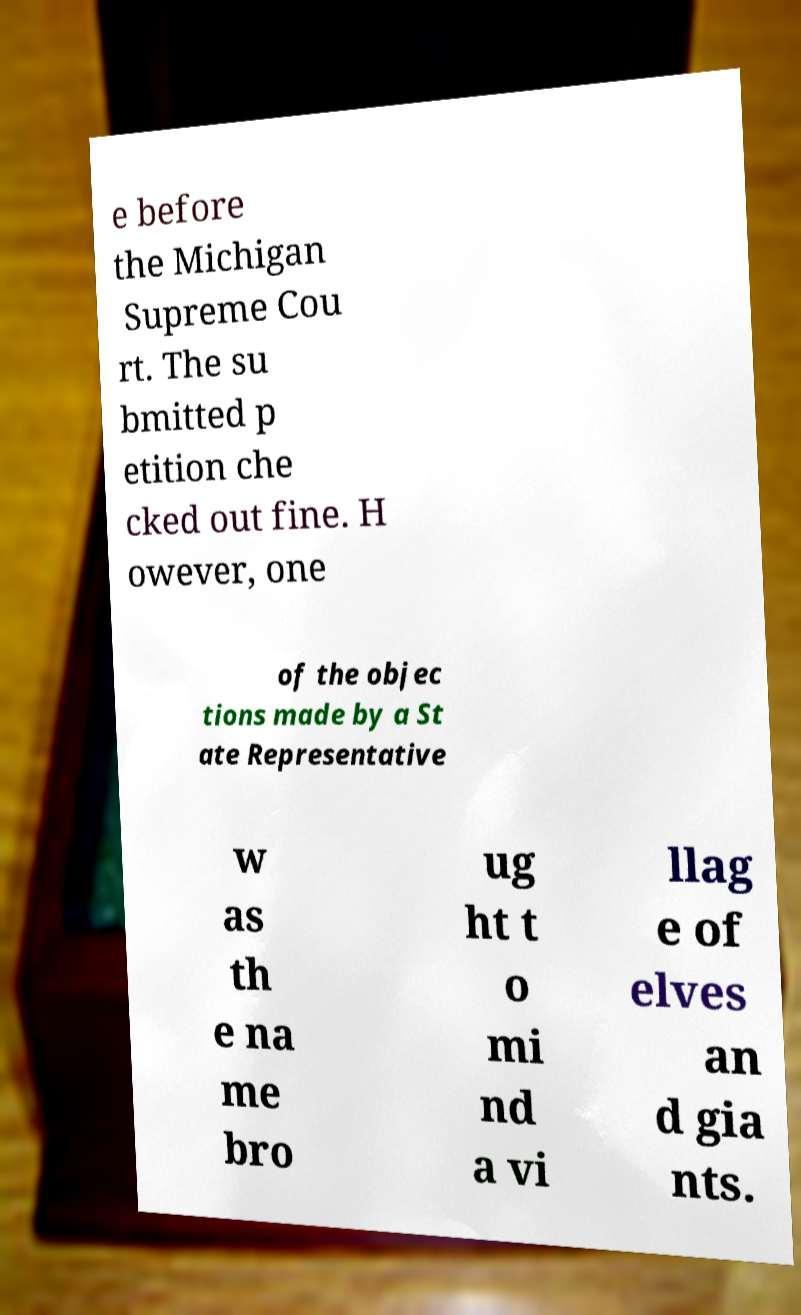Could you extract and type out the text from this image? e before the Michigan Supreme Cou rt. The su bmitted p etition che cked out fine. H owever, one of the objec tions made by a St ate Representative w as th e na me bro ug ht t o mi nd a vi llag e of elves an d gia nts. 